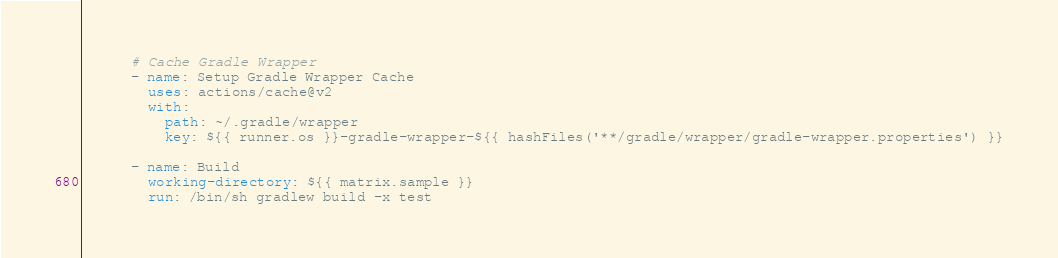Convert code to text. <code><loc_0><loc_0><loc_500><loc_500><_YAML_>
      # Cache Gradle Wrapper
      - name: Setup Gradle Wrapper Cache
        uses: actions/cache@v2
        with:
          path: ~/.gradle/wrapper
          key: ${{ runner.os }}-gradle-wrapper-${{ hashFiles('**/gradle/wrapper/gradle-wrapper.properties') }}

      - name: Build
        working-directory: ${{ matrix.sample }}
        run: /bin/sh gradlew build -x test
</code> 